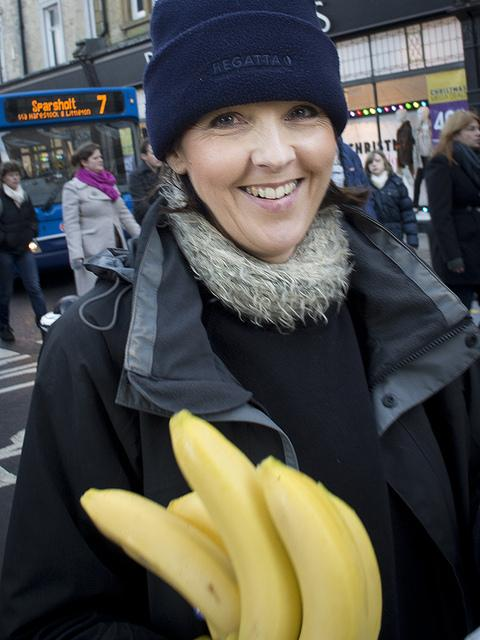The store behind the bus is having a sale due to which major event? Please explain your reasoning. christmas. The sign on the front of the store indicates the holiday that caused the sale. 